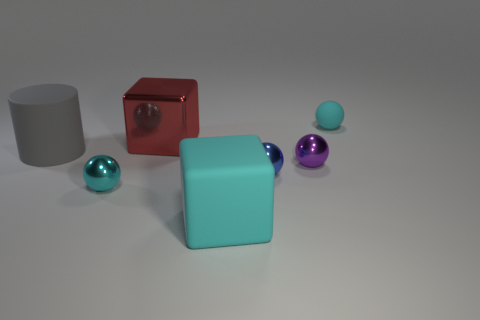How do the textures of the objects compare to each other? Each object in the image seems to have its unique texture. The large red cube has a rough, possibly metallic texture that reflects light unevenly, while the grey cylinder appears to have a smooth yet matte surface. The two smaller spheres, one purple and one sky blue, have highly reflective surfaces that suggest a polished texture, possibly like glass or plastic. The cyan cube has a more matte finish like the cylinder, which contrasts with the sheen of the spheres. 